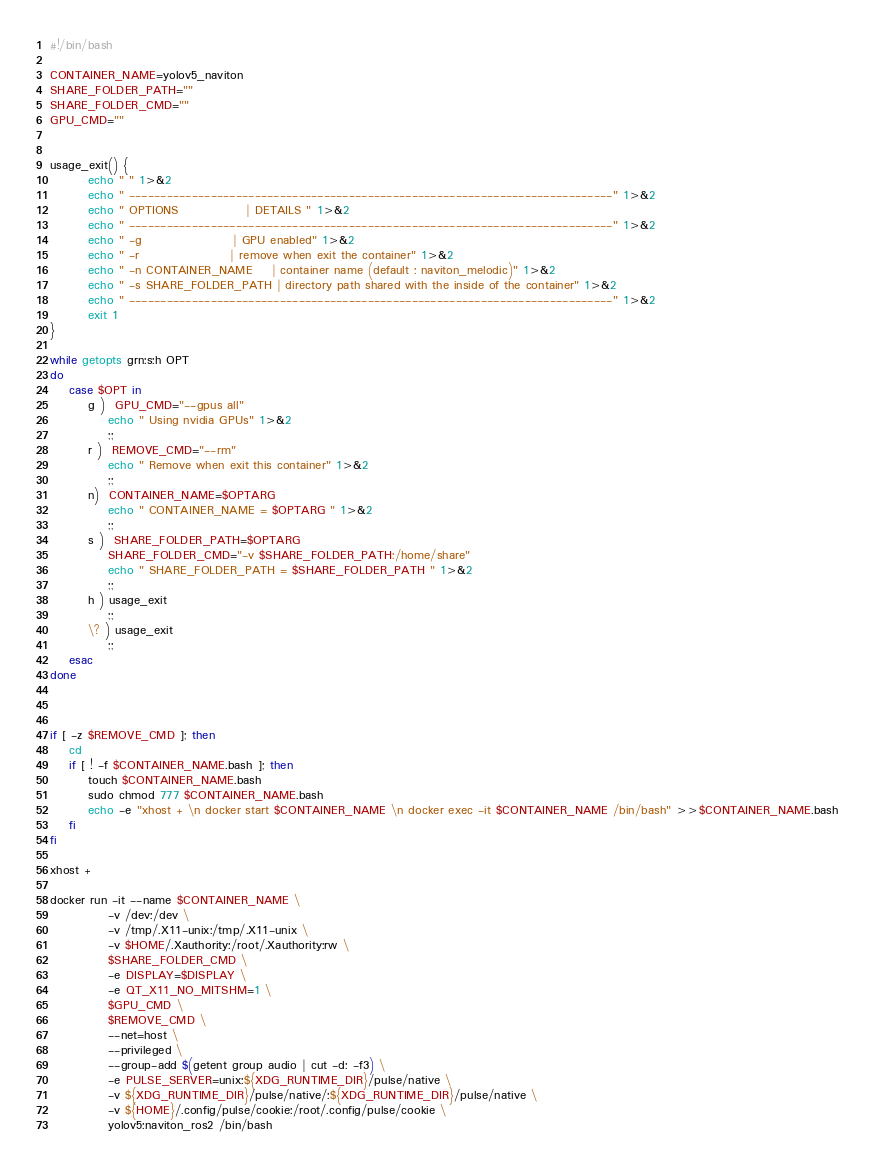Convert code to text. <code><loc_0><loc_0><loc_500><loc_500><_Bash_>#!/bin/bash

CONTAINER_NAME=yolov5_naviton
SHARE_FOLDER_PATH=""
SHARE_FOLDER_CMD=""
GPU_CMD=""


usage_exit() {
        echo " " 1>&2
        echo " -----------------------------------------------------------------------------" 1>&2
        echo " OPTIONS              | DETAILS " 1>&2
        echo " -----------------------------------------------------------------------------" 1>&2
        echo " -g                   | GPU enabled" 1>&2
        echo " -r                   | remove when exit the container" 1>&2
        echo " -n CONTAINER_NAME    | container name (default : naviton_melodic)" 1>&2
        echo " -s SHARE_FOLDER_PATH | directory path shared with the inside of the container" 1>&2
        echo " -----------------------------------------------------------------------------" 1>&2
        exit 1
}

while getopts grn:s:h OPT
do
    case $OPT in
        g )  GPU_CMD="--gpus all"
            echo " Using nvidia GPUs" 1>&2
            ;;
        r )  REMOVE_CMD="--rm"
            echo " Remove when exit this container" 1>&2
            ;;
        n)  CONTAINER_NAME=$OPTARG
            echo " CONTAINER_NAME = $OPTARG " 1>&2
            ;;
        s )  SHARE_FOLDER_PATH=$OPTARG
            SHARE_FOLDER_CMD="-v $SHARE_FOLDER_PATH:/home/share"
            echo " SHARE_FOLDER_PATH = $SHARE_FOLDER_PATH " 1>&2
            ;;
        h ) usage_exit
            ;;
        \? ) usage_exit
            ;;
    esac
done



if [ -z $REMOVE_CMD ]; then
    cd
    if [ ! -f $CONTAINER_NAME.bash ]; then
        touch $CONTAINER_NAME.bash
        sudo chmod 777 $CONTAINER_NAME.bash
        echo -e "xhost + \n docker start $CONTAINER_NAME \n docker exec -it $CONTAINER_NAME /bin/bash" >>$CONTAINER_NAME.bash
    fi
fi

xhost +

docker run -it --name $CONTAINER_NAME \
            -v /dev:/dev \
            -v /tmp/.X11-unix:/tmp/.X11-unix \
            -v $HOME/.Xauthority:/root/.Xauthority:rw \
            $SHARE_FOLDER_CMD \
            -e DISPLAY=$DISPLAY \
            -e QT_X11_NO_MITSHM=1 \
            $GPU_CMD \
            $REMOVE_CMD \
            --net=host \
            --privileged \
            --group-add $(getent group audio | cut -d: -f3) \
            -e PULSE_SERVER=unix:${XDG_RUNTIME_DIR}/pulse/native \
            -v ${XDG_RUNTIME_DIR}/pulse/native/:${XDG_RUNTIME_DIR}/pulse/native \
            -v ${HOME}/.config/pulse/cookie:/root/.config/pulse/cookie \
            yolov5:naviton_ros2 /bin/bash

</code> 